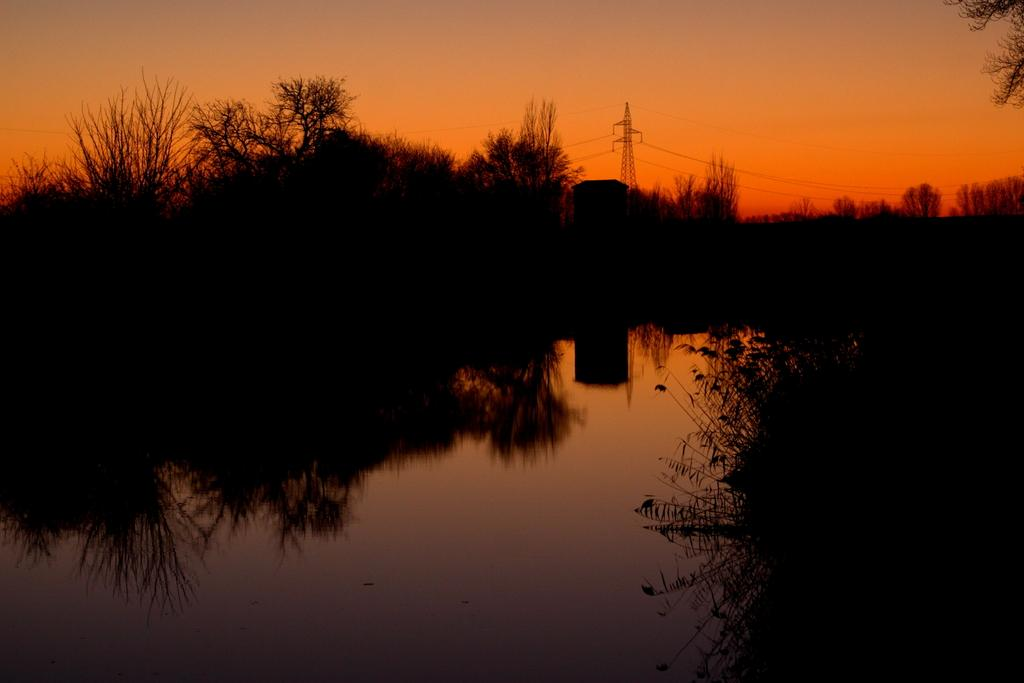What is in the foreground of the image? There is water and trees in the foreground of the image. What can be seen in the background of the image? There is a tower, cables, and the sky visible in the background of the image. What type of seed is the duck planting in the image? There is no duck or seed present in the image. What is the minister doing in the image? There is no minister present in the image. 